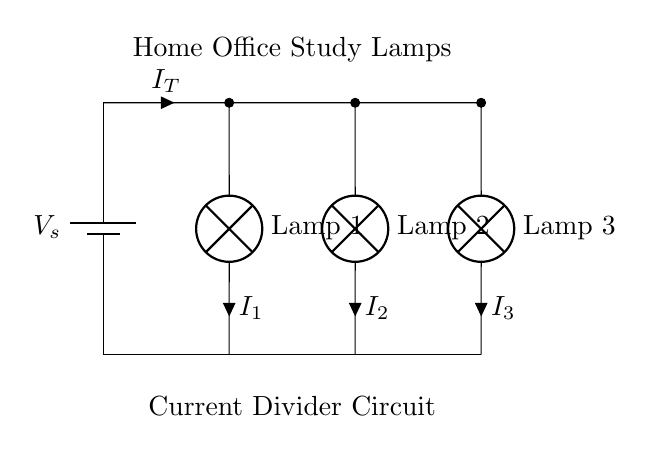What is the total current entering the circuit? The total current, denoted as I_T, is represented in the diagram next to the main current path leading into the parallel branches of the lamps.
Answer: I_T How many lamps are connected in parallel? The circuit diagram clearly shows three distinct lamp branches connected parallel to one another, each receiving power from the same voltage source.
Answer: Three What is the function of the lamps in this circuit? The lamps serve as the loads of the circuit, converting electrical energy from the current into light. This is evident as each lamp is depicted as a component with an associated current label.
Answer: Load If the voltage across the lamps is constant, how does the current divide among the lamps? In a current divider circuit, the current divides among the parallel branches based on the resistances of the loads. Given that the lamps are identical, the current would split equally.
Answer: Equally What is the purpose of the battery in this circuit? The battery provides the direct current voltage source needed to power the lamps, and it is indicated at the start of the circuit.
Answer: Power source What does I_1 represent in this circuit? I_1 represents the current flowing through Lamp 1, and it is labeled next to the lamp indicating the specific branch of the current divider.
Answer: Current through Lamp 1 